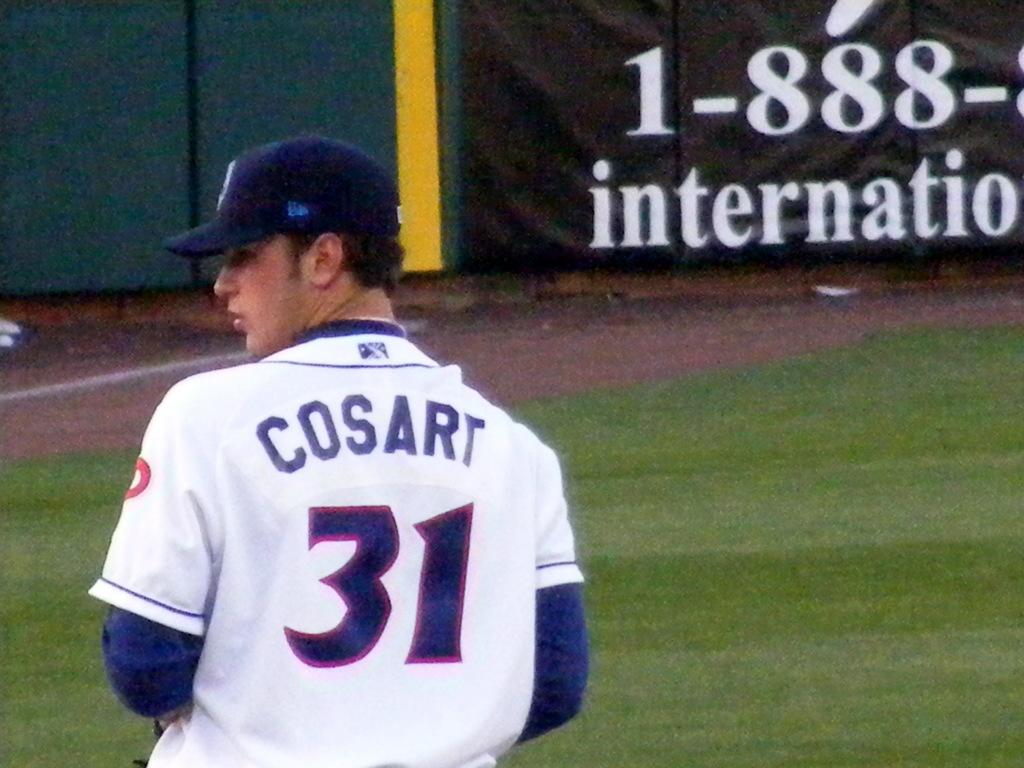<image>
Summarize the visual content of the image. A ball player with the name COSART on their jersey. 